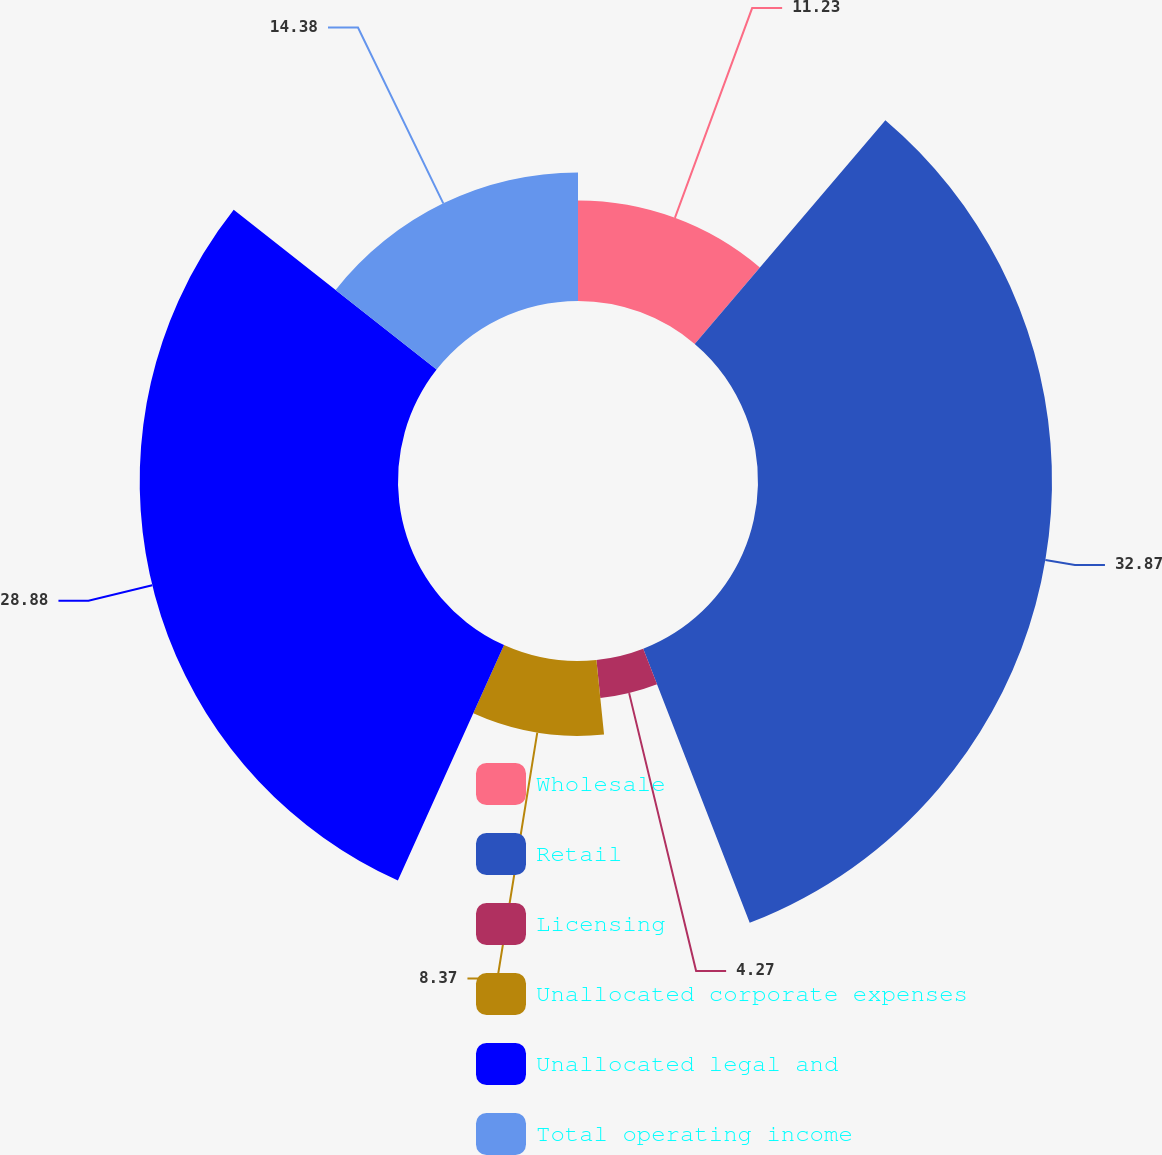Convert chart to OTSL. <chart><loc_0><loc_0><loc_500><loc_500><pie_chart><fcel>Wholesale<fcel>Retail<fcel>Licensing<fcel>Unallocated corporate expenses<fcel>Unallocated legal and<fcel>Total operating income<nl><fcel>11.23%<fcel>32.87%<fcel>4.27%<fcel>8.37%<fcel>28.88%<fcel>14.38%<nl></chart> 